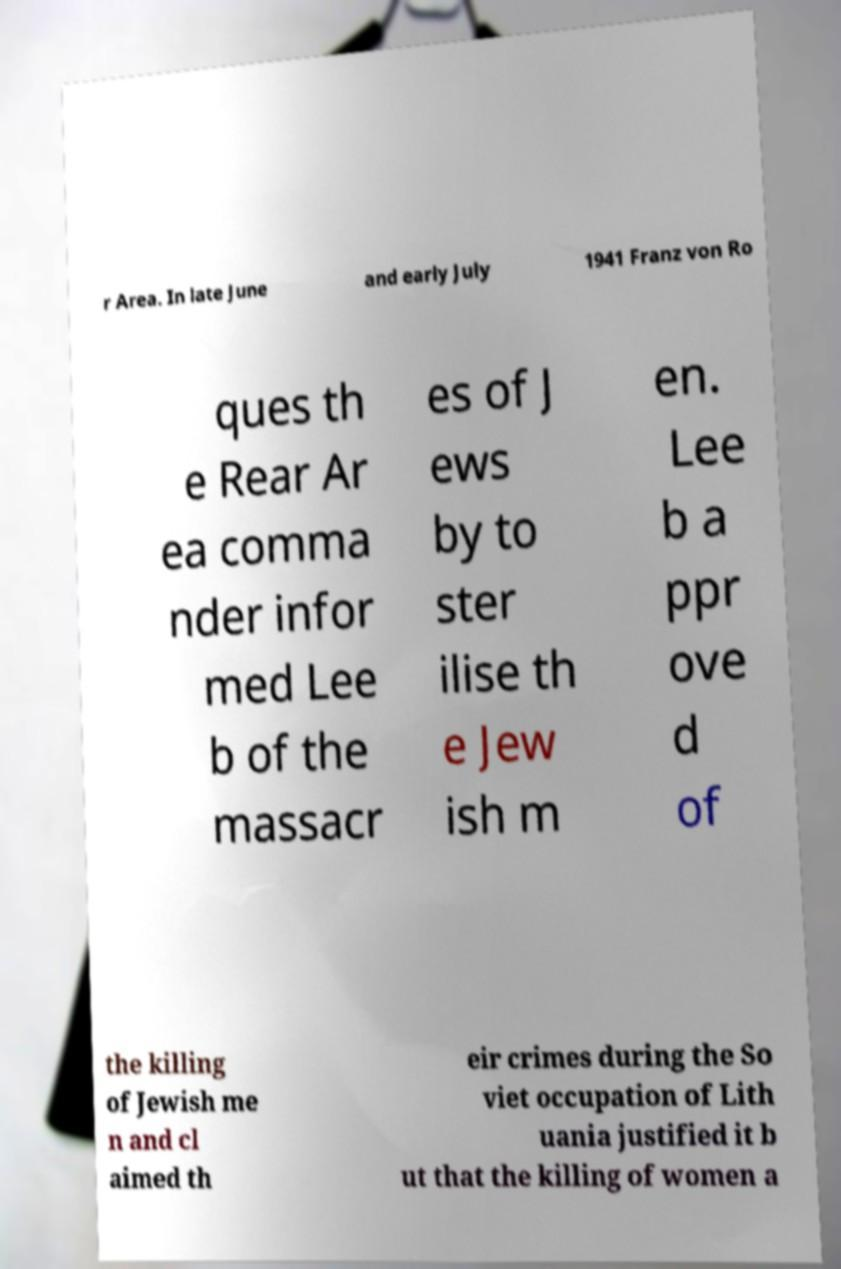What messages or text are displayed in this image? I need them in a readable, typed format. r Area. In late June and early July 1941 Franz von Ro ques th e Rear Ar ea comma nder infor med Lee b of the massacr es of J ews by to ster ilise th e Jew ish m en. Lee b a ppr ove d of the killing of Jewish me n and cl aimed th eir crimes during the So viet occupation of Lith uania justified it b ut that the killing of women a 